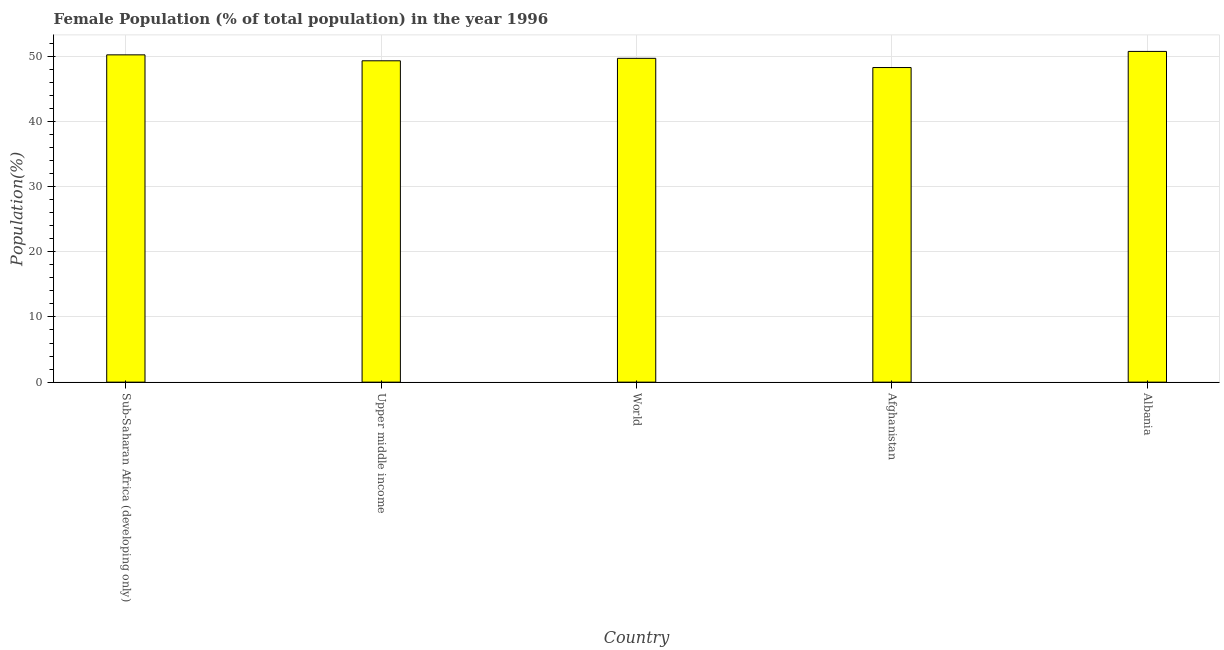Does the graph contain any zero values?
Offer a very short reply. No. Does the graph contain grids?
Keep it short and to the point. Yes. What is the title of the graph?
Provide a succinct answer. Female Population (% of total population) in the year 1996. What is the label or title of the Y-axis?
Ensure brevity in your answer.  Population(%). What is the female population in Albania?
Your answer should be very brief. 50.73. Across all countries, what is the maximum female population?
Your answer should be compact. 50.73. Across all countries, what is the minimum female population?
Ensure brevity in your answer.  48.26. In which country was the female population maximum?
Keep it short and to the point. Albania. In which country was the female population minimum?
Keep it short and to the point. Afghanistan. What is the sum of the female population?
Your response must be concise. 248.15. What is the difference between the female population in Afghanistan and Sub-Saharan Africa (developing only)?
Provide a succinct answer. -1.94. What is the average female population per country?
Offer a terse response. 49.63. What is the median female population?
Your answer should be very brief. 49.67. In how many countries, is the female population greater than 20 %?
Offer a very short reply. 5. Is the female population in Albania less than that in World?
Give a very brief answer. No. Is the difference between the female population in Albania and Upper middle income greater than the difference between any two countries?
Offer a terse response. No. What is the difference between the highest and the second highest female population?
Ensure brevity in your answer.  0.53. Is the sum of the female population in Sub-Saharan Africa (developing only) and Upper middle income greater than the maximum female population across all countries?
Provide a succinct answer. Yes. What is the difference between the highest and the lowest female population?
Your answer should be compact. 2.47. In how many countries, is the female population greater than the average female population taken over all countries?
Offer a terse response. 3. Are all the bars in the graph horizontal?
Your response must be concise. No. How many countries are there in the graph?
Your answer should be compact. 5. Are the values on the major ticks of Y-axis written in scientific E-notation?
Provide a succinct answer. No. What is the Population(%) of Sub-Saharan Africa (developing only)?
Provide a short and direct response. 50.2. What is the Population(%) of Upper middle income?
Your answer should be compact. 49.29. What is the Population(%) in World?
Offer a terse response. 49.67. What is the Population(%) in Afghanistan?
Your answer should be very brief. 48.26. What is the Population(%) of Albania?
Provide a succinct answer. 50.73. What is the difference between the Population(%) in Sub-Saharan Africa (developing only) and Upper middle income?
Your answer should be compact. 0.91. What is the difference between the Population(%) in Sub-Saharan Africa (developing only) and World?
Offer a very short reply. 0.53. What is the difference between the Population(%) in Sub-Saharan Africa (developing only) and Afghanistan?
Offer a terse response. 1.94. What is the difference between the Population(%) in Sub-Saharan Africa (developing only) and Albania?
Provide a succinct answer. -0.53. What is the difference between the Population(%) in Upper middle income and World?
Ensure brevity in your answer.  -0.38. What is the difference between the Population(%) in Upper middle income and Afghanistan?
Keep it short and to the point. 1.03. What is the difference between the Population(%) in Upper middle income and Albania?
Your response must be concise. -1.44. What is the difference between the Population(%) in World and Afghanistan?
Provide a short and direct response. 1.41. What is the difference between the Population(%) in World and Albania?
Offer a very short reply. -1.06. What is the difference between the Population(%) in Afghanistan and Albania?
Your answer should be compact. -2.47. What is the ratio of the Population(%) in Sub-Saharan Africa (developing only) to that in Upper middle income?
Offer a terse response. 1.02. What is the ratio of the Population(%) in Sub-Saharan Africa (developing only) to that in World?
Your answer should be very brief. 1.01. What is the ratio of the Population(%) in Upper middle income to that in World?
Provide a short and direct response. 0.99. What is the ratio of the Population(%) in World to that in Albania?
Ensure brevity in your answer.  0.98. What is the ratio of the Population(%) in Afghanistan to that in Albania?
Offer a terse response. 0.95. 